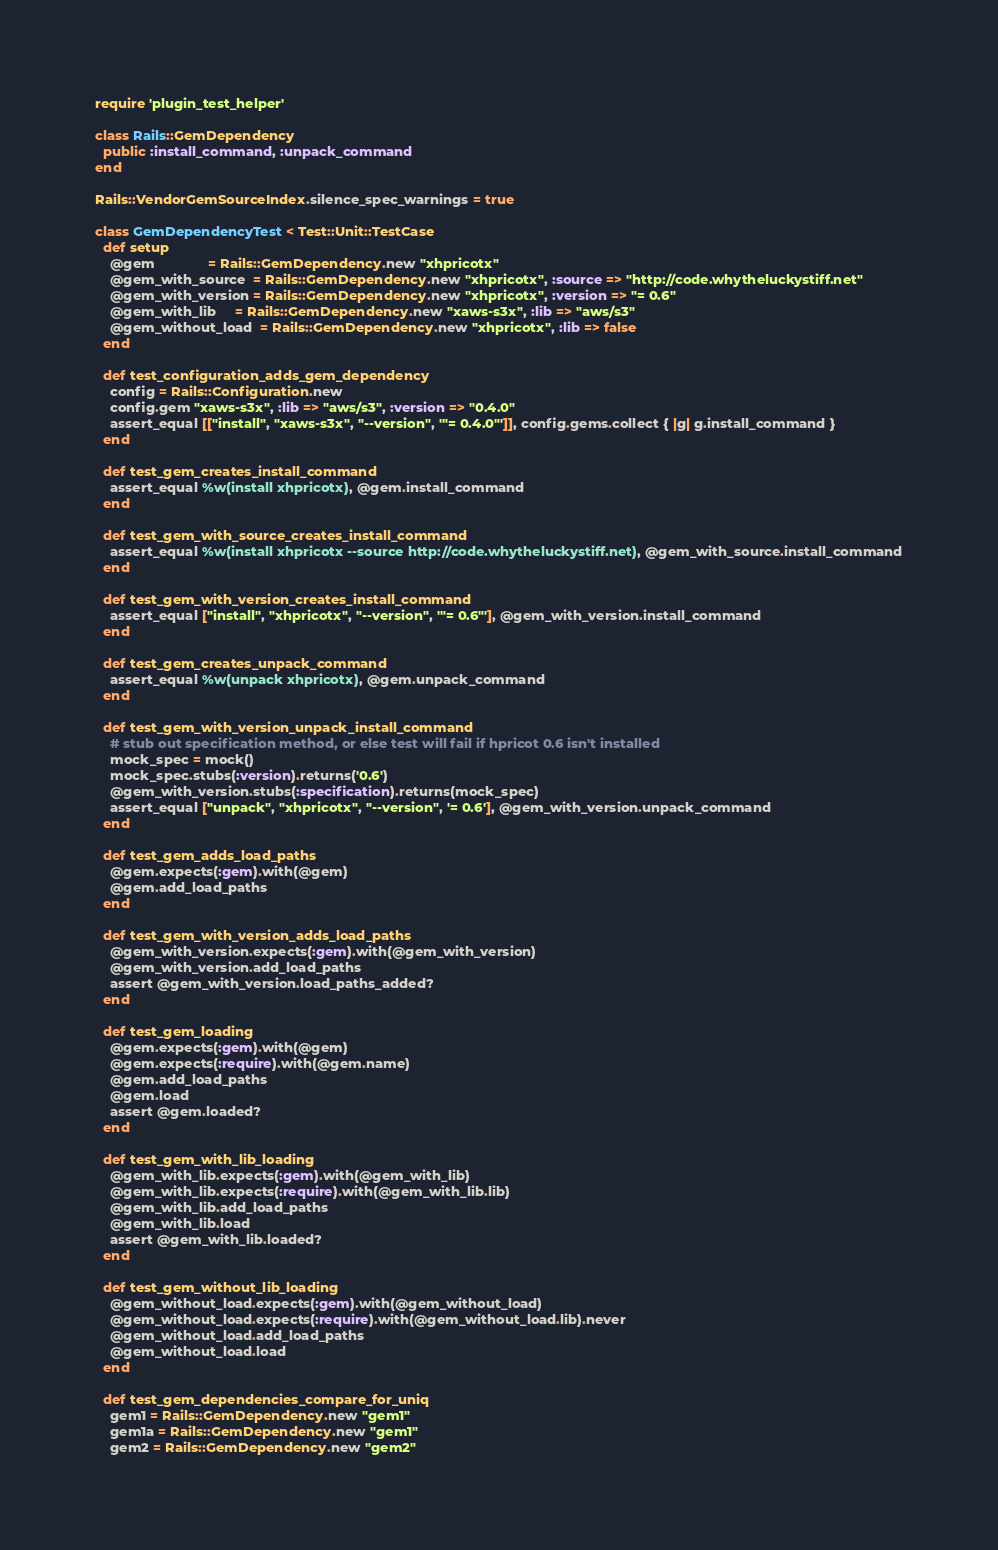Convert code to text. <code><loc_0><loc_0><loc_500><loc_500><_Ruby_>require 'plugin_test_helper'

class Rails::GemDependency
  public :install_command, :unpack_command
end

Rails::VendorGemSourceIndex.silence_spec_warnings = true

class GemDependencyTest < Test::Unit::TestCase
  def setup
    @gem              = Rails::GemDependency.new "xhpricotx"
    @gem_with_source  = Rails::GemDependency.new "xhpricotx", :source => "http://code.whytheluckystiff.net"
    @gem_with_version = Rails::GemDependency.new "xhpricotx", :version => "= 0.6"
    @gem_with_lib     = Rails::GemDependency.new "xaws-s3x", :lib => "aws/s3"
    @gem_without_load  = Rails::GemDependency.new "xhpricotx", :lib => false
  end

  def test_configuration_adds_gem_dependency
    config = Rails::Configuration.new
    config.gem "xaws-s3x", :lib => "aws/s3", :version => "0.4.0"
    assert_equal [["install", "xaws-s3x", "--version", '"= 0.4.0"']], config.gems.collect { |g| g.install_command }
  end

  def test_gem_creates_install_command
    assert_equal %w(install xhpricotx), @gem.install_command
  end

  def test_gem_with_source_creates_install_command
    assert_equal %w(install xhpricotx --source http://code.whytheluckystiff.net), @gem_with_source.install_command
  end

  def test_gem_with_version_creates_install_command
    assert_equal ["install", "xhpricotx", "--version", '"= 0.6"'], @gem_with_version.install_command
  end

  def test_gem_creates_unpack_command
    assert_equal %w(unpack xhpricotx), @gem.unpack_command
  end

  def test_gem_with_version_unpack_install_command
    # stub out specification method, or else test will fail if hpricot 0.6 isn't installed
    mock_spec = mock()
    mock_spec.stubs(:version).returns('0.6')
    @gem_with_version.stubs(:specification).returns(mock_spec)
    assert_equal ["unpack", "xhpricotx", "--version", '= 0.6'], @gem_with_version.unpack_command
  end

  def test_gem_adds_load_paths
    @gem.expects(:gem).with(@gem)
    @gem.add_load_paths
  end

  def test_gem_with_version_adds_load_paths
    @gem_with_version.expects(:gem).with(@gem_with_version)
    @gem_with_version.add_load_paths
    assert @gem_with_version.load_paths_added?
  end

  def test_gem_loading
    @gem.expects(:gem).with(@gem)
    @gem.expects(:require).with(@gem.name)
    @gem.add_load_paths
    @gem.load
    assert @gem.loaded?
  end

  def test_gem_with_lib_loading
    @gem_with_lib.expects(:gem).with(@gem_with_lib)
    @gem_with_lib.expects(:require).with(@gem_with_lib.lib)
    @gem_with_lib.add_load_paths
    @gem_with_lib.load
    assert @gem_with_lib.loaded?
  end

  def test_gem_without_lib_loading
    @gem_without_load.expects(:gem).with(@gem_without_load)
    @gem_without_load.expects(:require).with(@gem_without_load.lib).never
    @gem_without_load.add_load_paths
    @gem_without_load.load
  end

  def test_gem_dependencies_compare_for_uniq
    gem1 = Rails::GemDependency.new "gem1"
    gem1a = Rails::GemDependency.new "gem1"
    gem2 = Rails::GemDependency.new "gem2"</code> 